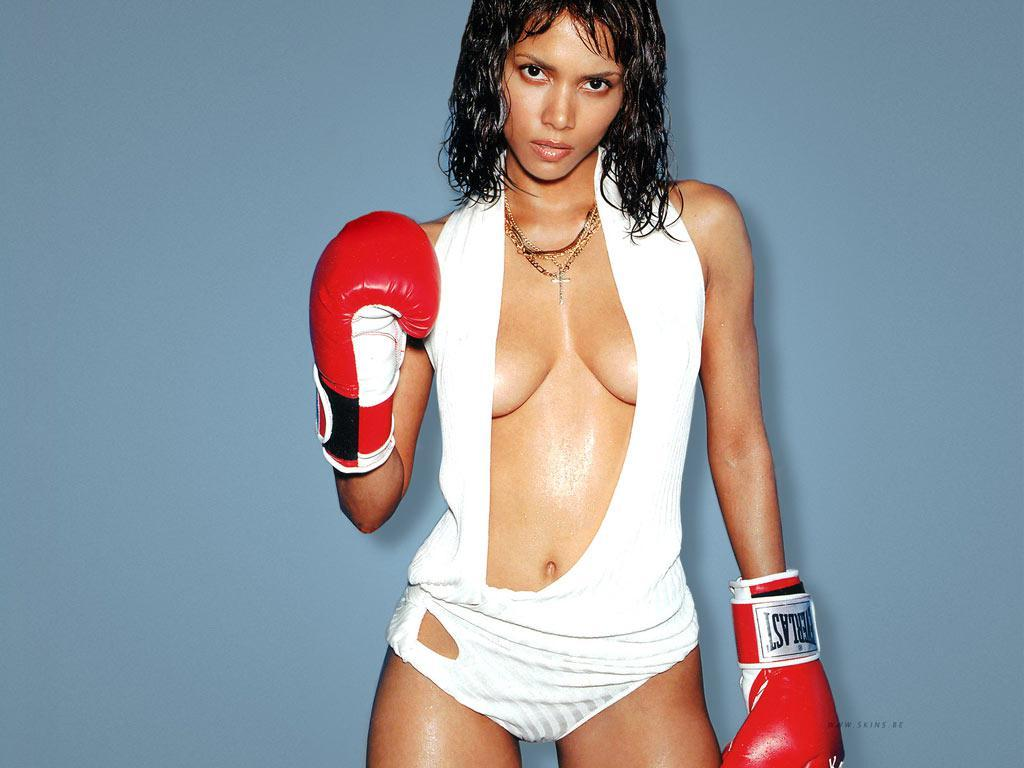Who is present in the image? There is a woman in the image. What is the woman doing in the image? The woman is standing in the image. What is the woman wearing in the image? The woman is wearing a white dress and boxing gloves in the image. What can be seen in the background of the image? The background of the image appears to be blue in color. What type of yarn is the woman using to create a knitted masterpiece in the image? There is no yarn or knitting activity present in the image; the woman is wearing boxing gloves. Can you describe the seashore visible in the background of the image? There is no seashore present in the image; the background appears to be blue in color. 